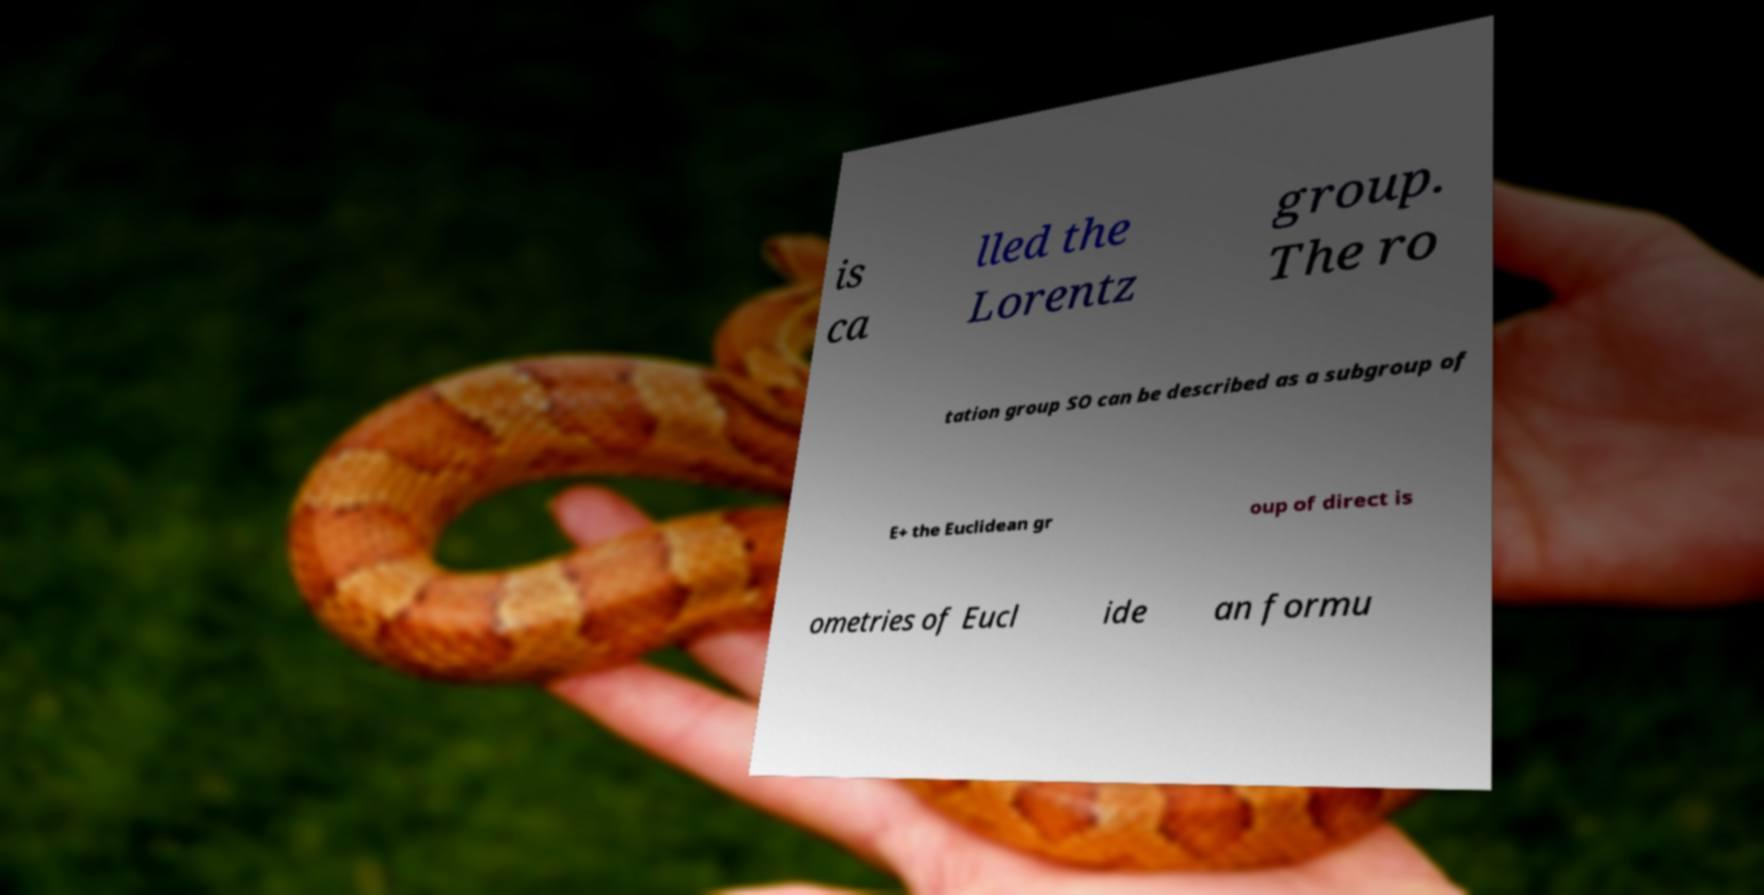Could you extract and type out the text from this image? is ca lled the Lorentz group. The ro tation group SO can be described as a subgroup of E+ the Euclidean gr oup of direct is ometries of Eucl ide an formu 